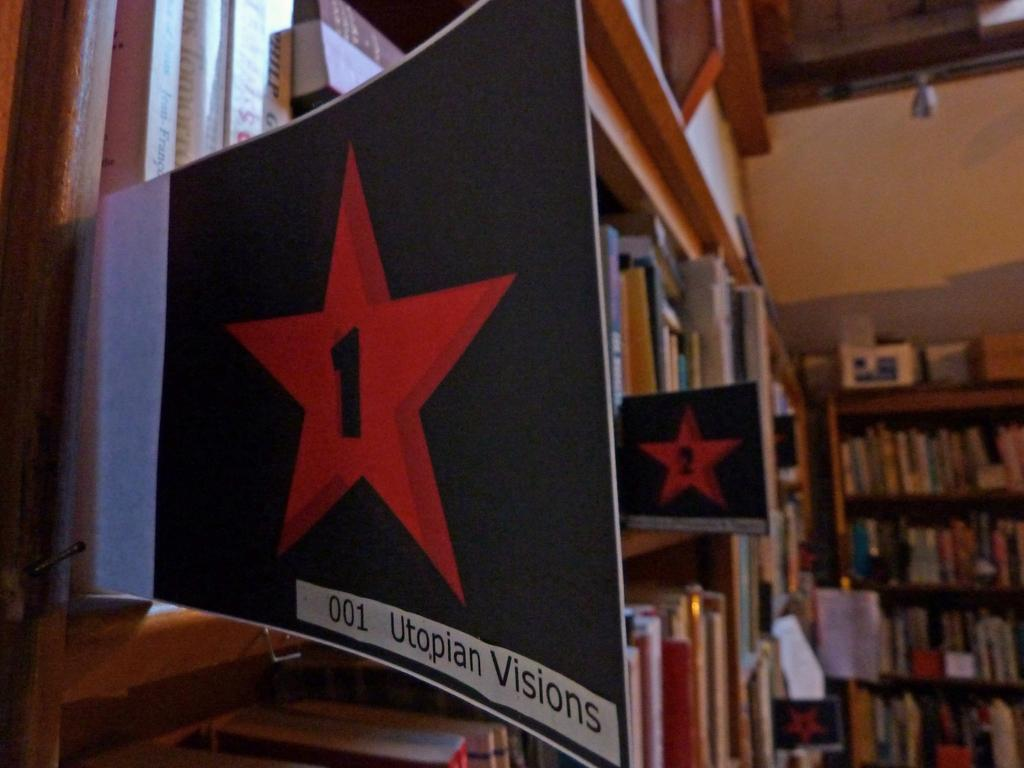<image>
Offer a succinct explanation of the picture presented. The inside of a libary with books on shelves and a section of them is called Utopian Visions. 